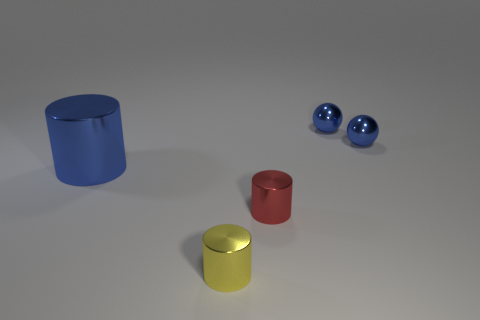Is there anything else that is the same material as the blue cylinder?
Your answer should be very brief. Yes. Is there a red object that has the same shape as the big blue object?
Your response must be concise. Yes. There is a yellow cylinder that is the same size as the red object; what is it made of?
Your answer should be very brief. Metal. There is a cylinder left of the yellow thing; how big is it?
Give a very brief answer. Large. There is a object that is in front of the red metallic object; is its size the same as the cylinder right of the small yellow cylinder?
Provide a short and direct response. Yes. How many small blue things are the same material as the blue cylinder?
Your answer should be compact. 2. What color is the large cylinder?
Ensure brevity in your answer.  Blue. Are there any tiny red cylinders behind the tiny red metal cylinder?
Ensure brevity in your answer.  No. What number of small metal things have the same color as the big thing?
Your response must be concise. 2. How big is the metallic cylinder right of the thing that is in front of the small red thing?
Your response must be concise. Small. 